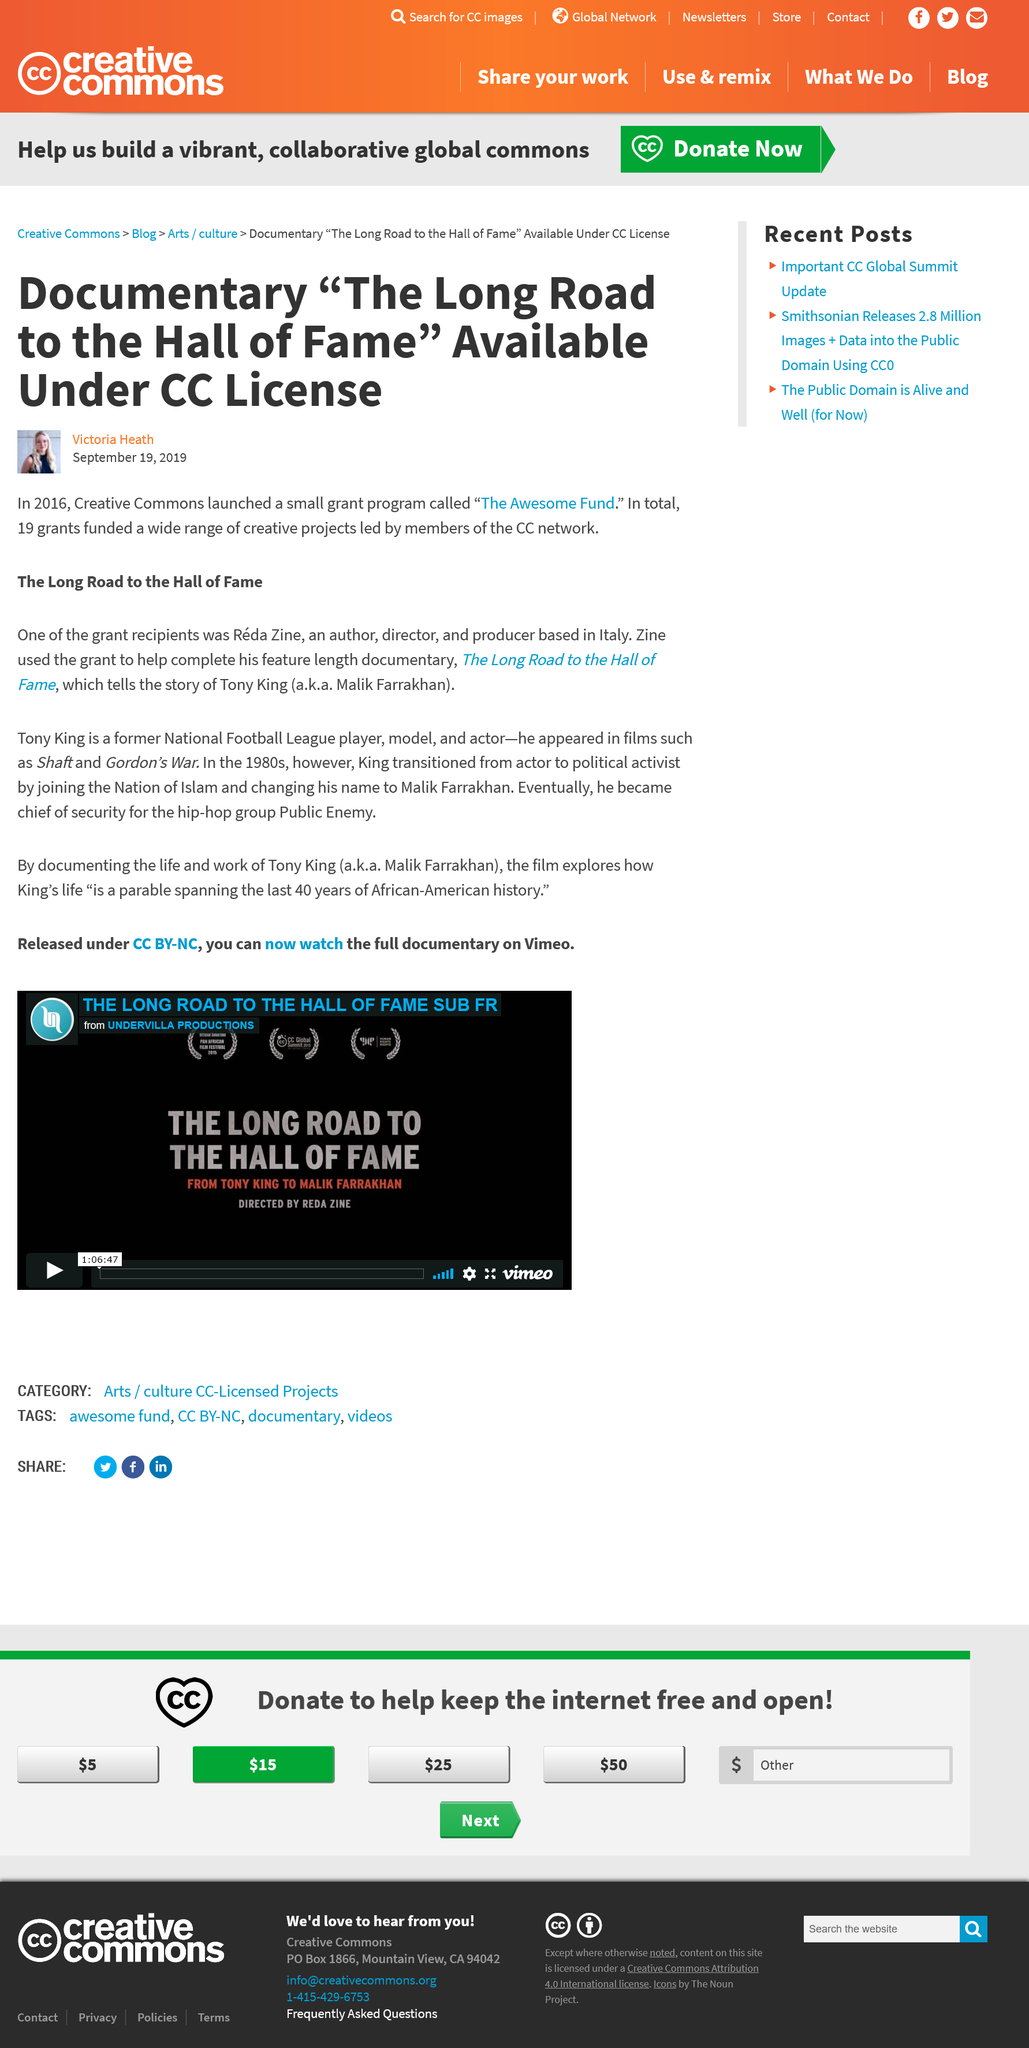Identify some key points in this picture. A total of 19 grants were awarded. Reda Zine used his grant to complete a documentary called "The Long Road to the Hall of Fame. The Awesome Fund was the name of the grant program. 